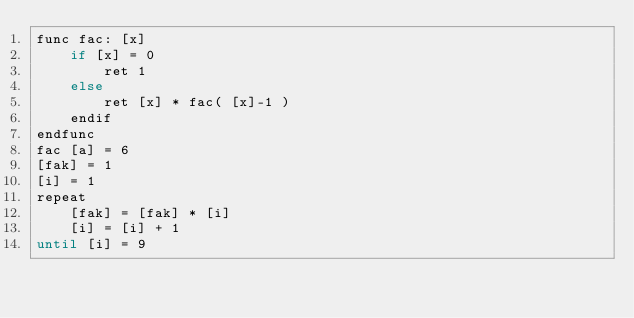Convert code to text. <code><loc_0><loc_0><loc_500><loc_500><_Ruby_>func fac: [x]
	if [x] = 0
		ret 1
	else
		ret [x] * fac( [x]-1 )
	endif
endfunc
fac [a] = 6
[fak] = 1
[i] = 1 
repeat
	[fak] = [fak] * [i]
	[i] = [i] + 1
until [i] = 9


</code> 